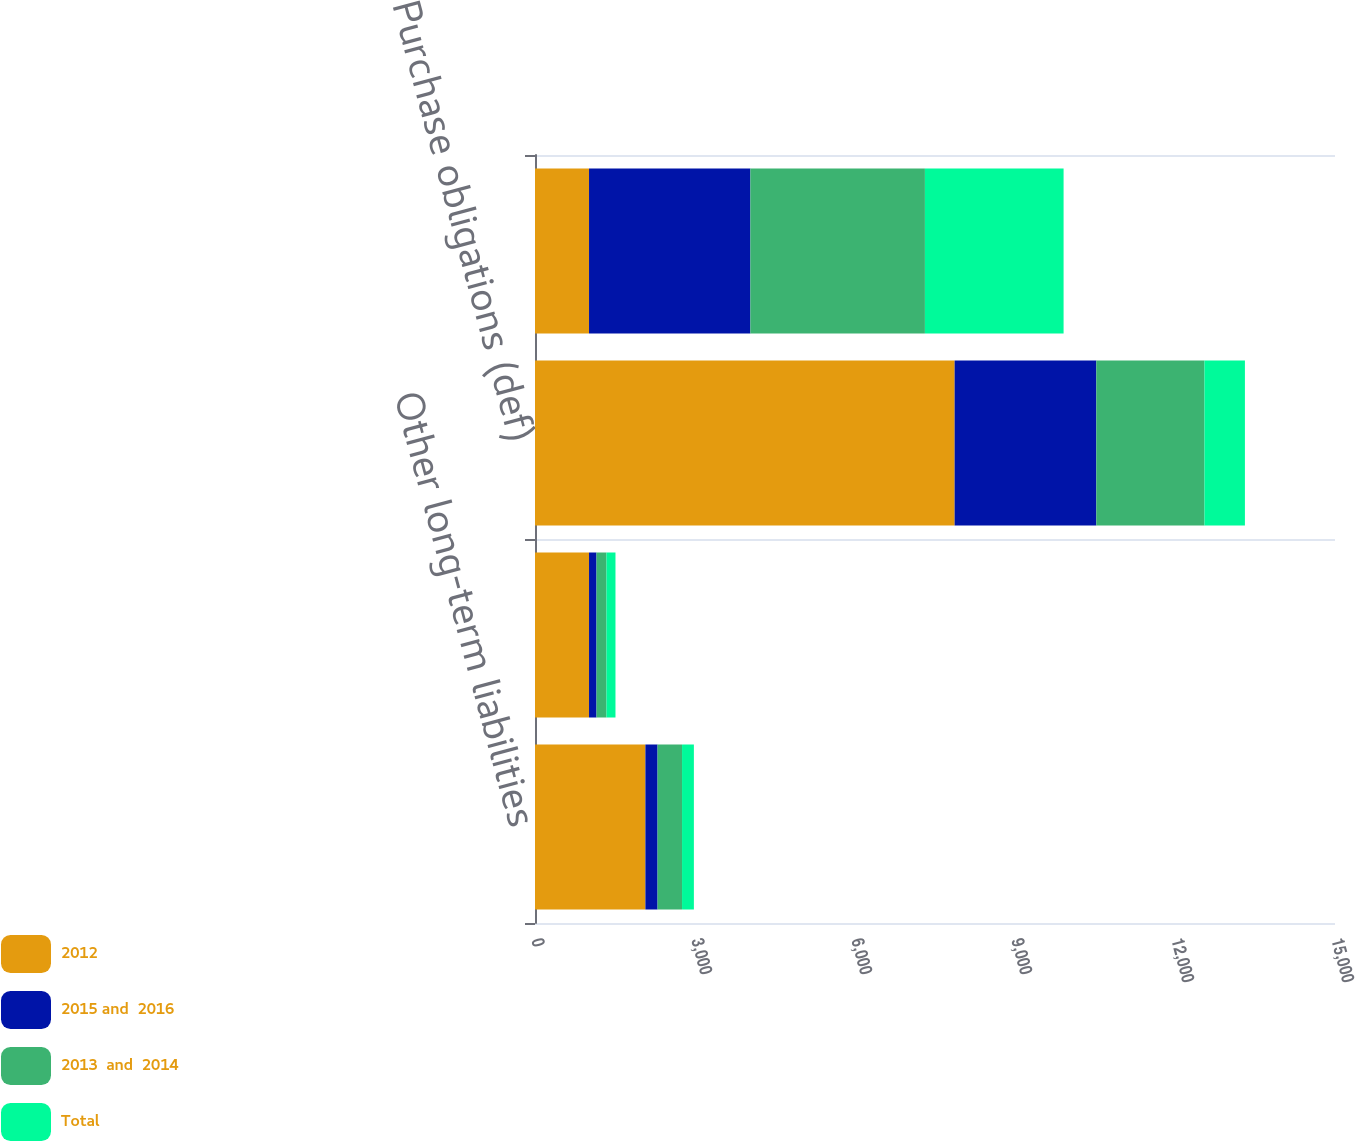Convert chart to OTSL. <chart><loc_0><loc_0><loc_500><loc_500><stacked_bar_chart><ecel><fcel>Other long-term liabilities<fcel>Operating leases (Note 6) (c)<fcel>Purchase obligations (def)<fcel>Total<nl><fcel>2012<fcel>2070<fcel>1013<fcel>7868<fcel>1013<nl><fcel>2015 and  2016<fcel>228<fcel>140<fcel>2657<fcel>3025<nl><fcel>2013  and  2014<fcel>459<fcel>187<fcel>2027<fcel>3273<nl><fcel>Total<fcel>222<fcel>169<fcel>759<fcel>2600<nl></chart> 